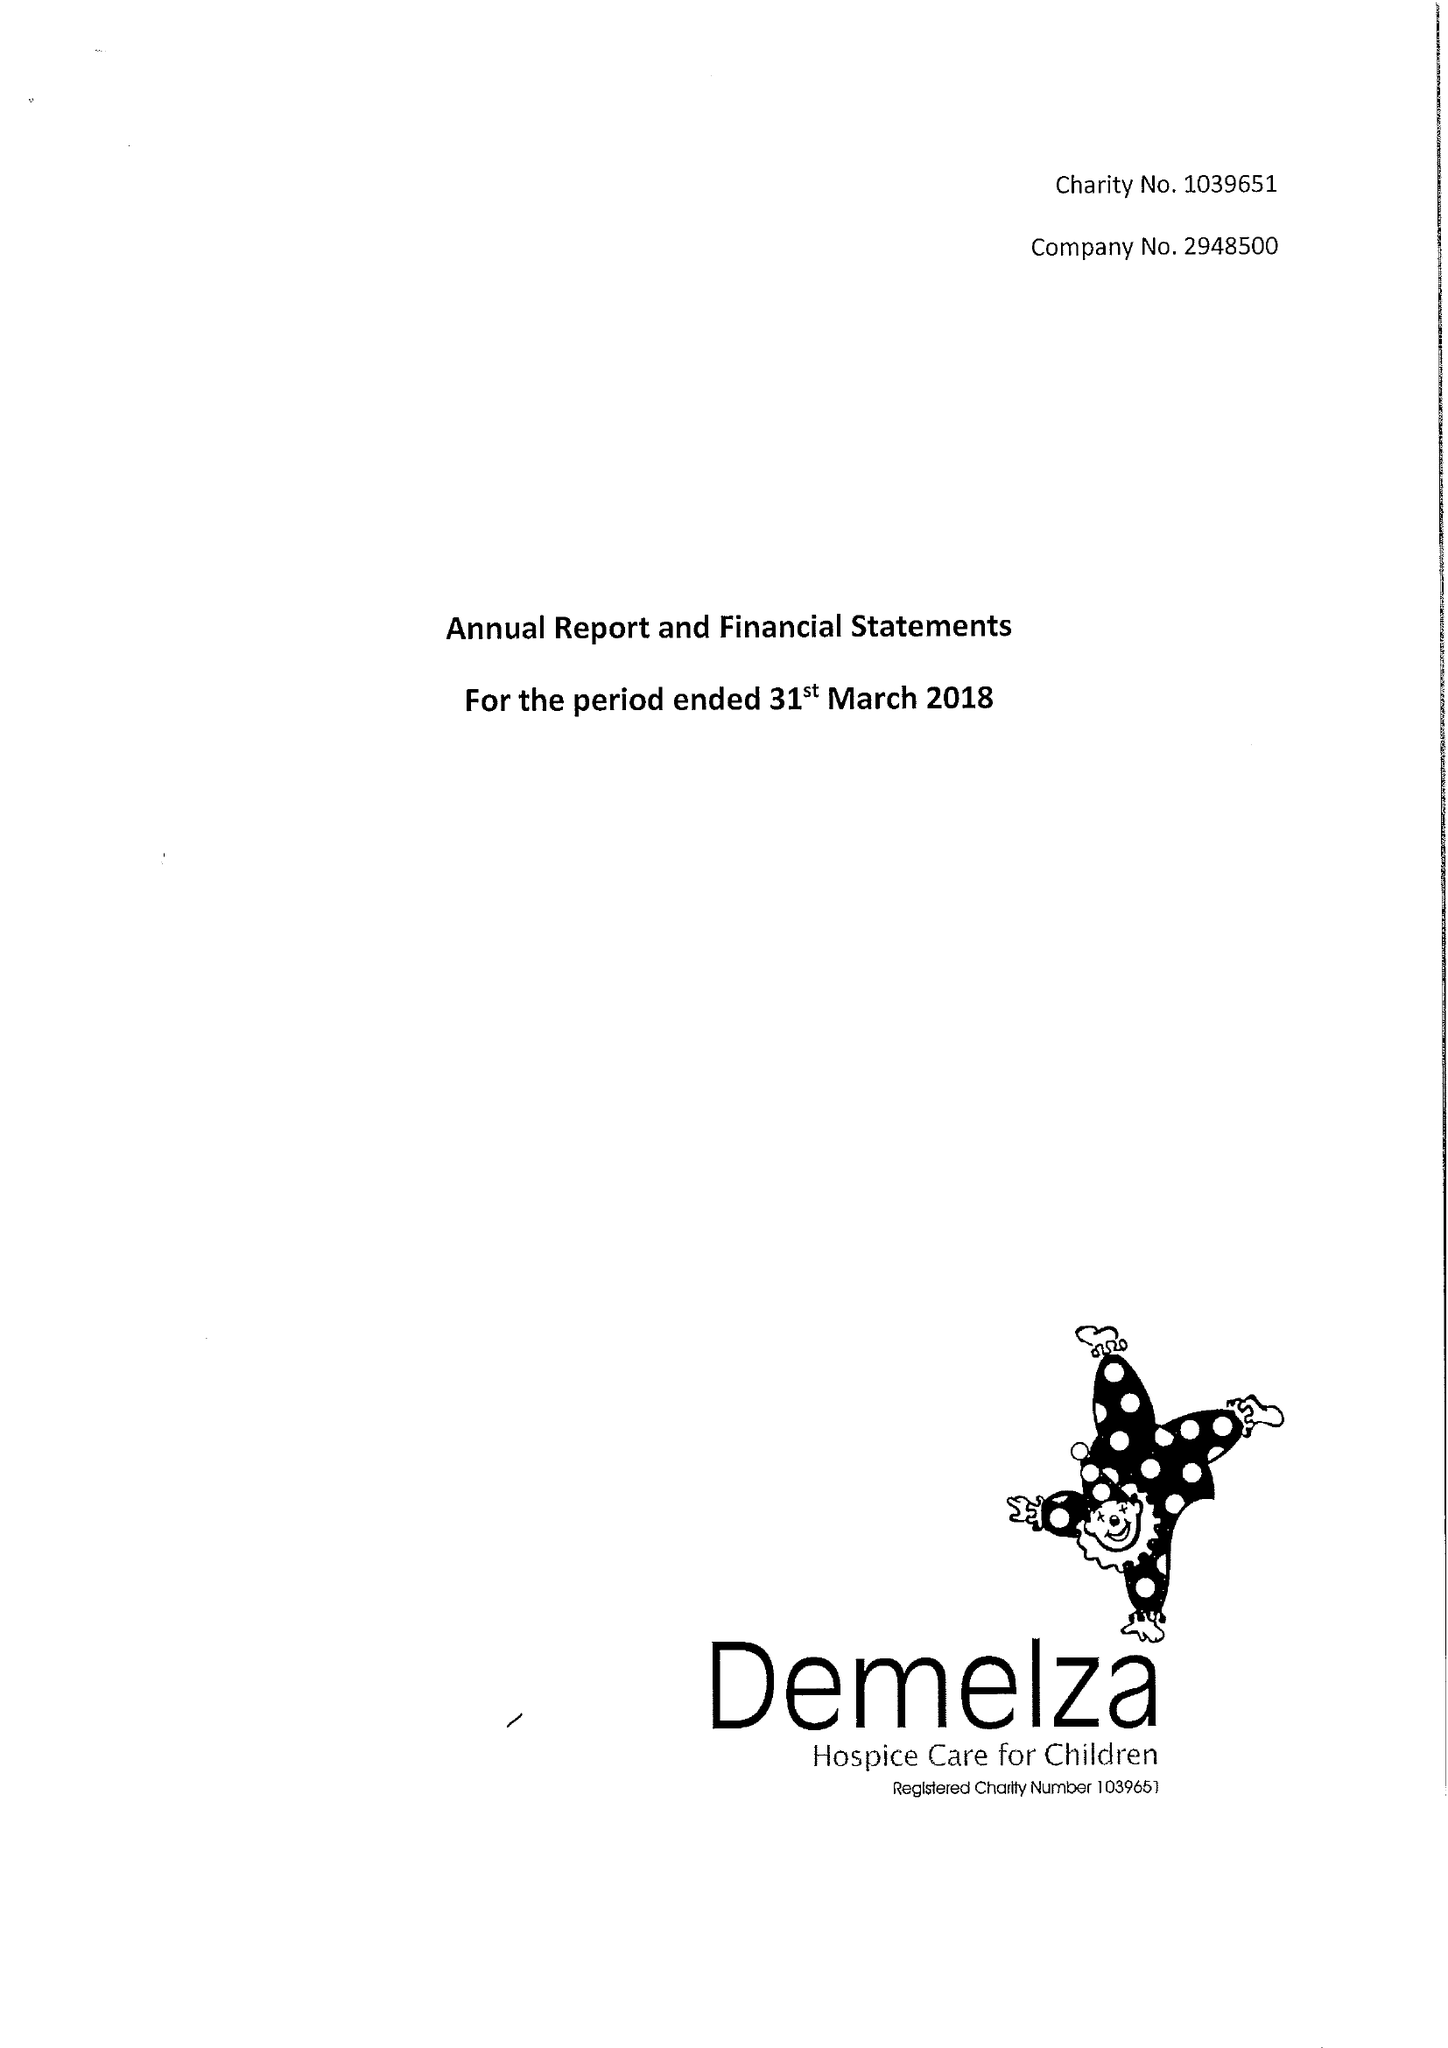What is the value for the address__street_line?
Answer the question using a single word or phrase. ROOK LANE 